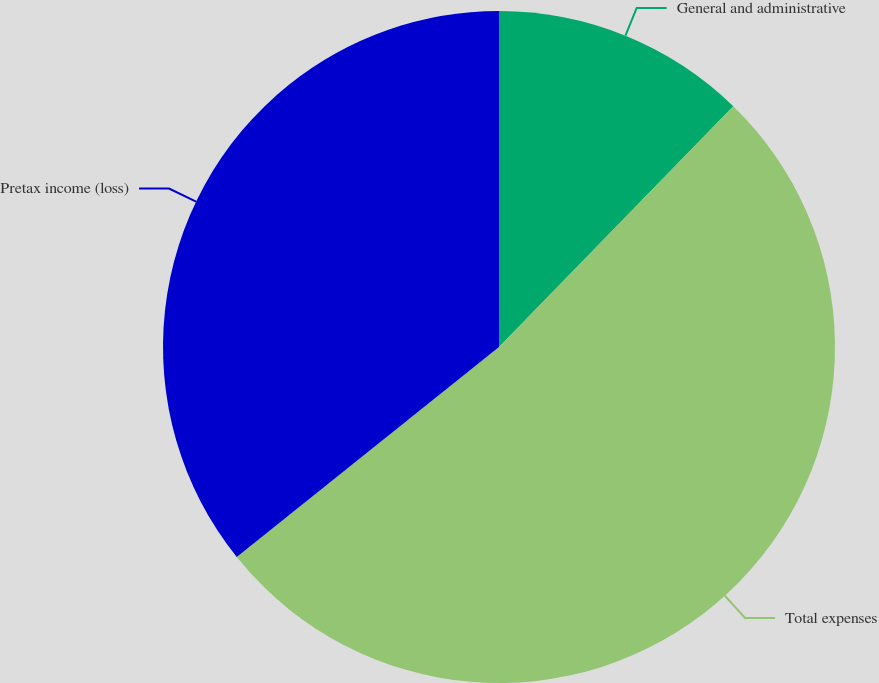Convert chart to OTSL. <chart><loc_0><loc_0><loc_500><loc_500><pie_chart><fcel>General and administrative<fcel>Total expenses<fcel>Pretax income (loss)<nl><fcel>12.28%<fcel>51.97%<fcel>35.75%<nl></chart> 